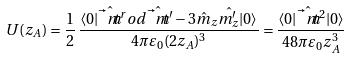Convert formula to latex. <formula><loc_0><loc_0><loc_500><loc_500>U ( z _ { A } ) = \frac { 1 } { 2 } \, \frac { \langle 0 | \hat { \vec { t } { m } } ^ { r } o d \hat { \vec { t } { m } } ^ { \prime } - 3 \hat { m } _ { z } \hat { m ^ { \prime } _ { z } } | 0 \rangle } { 4 \pi \varepsilon _ { 0 } ( 2 z _ { A } ) ^ { 3 } } = \frac { \langle 0 | \hat { \vec { t } { m } } ^ { 2 } | 0 \rangle } { 4 8 \pi \varepsilon _ { 0 } z _ { A } ^ { 3 } }</formula> 